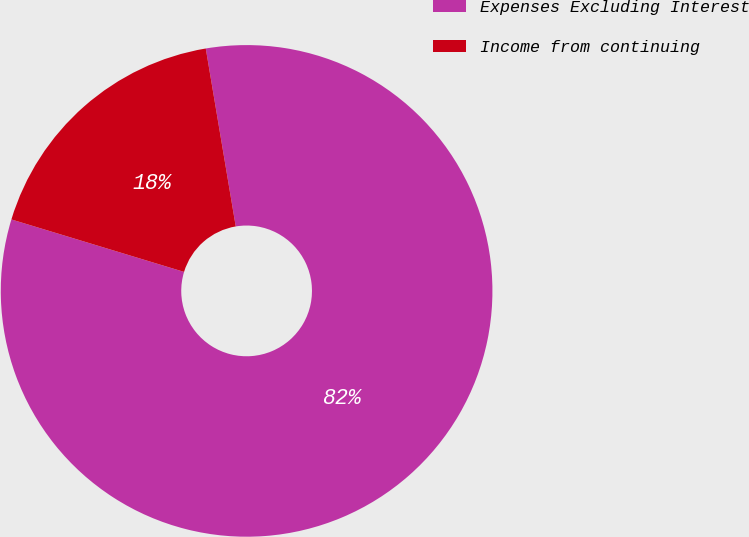Convert chart to OTSL. <chart><loc_0><loc_0><loc_500><loc_500><pie_chart><fcel>Expenses Excluding Interest<fcel>Income from continuing<nl><fcel>82.35%<fcel>17.65%<nl></chart> 